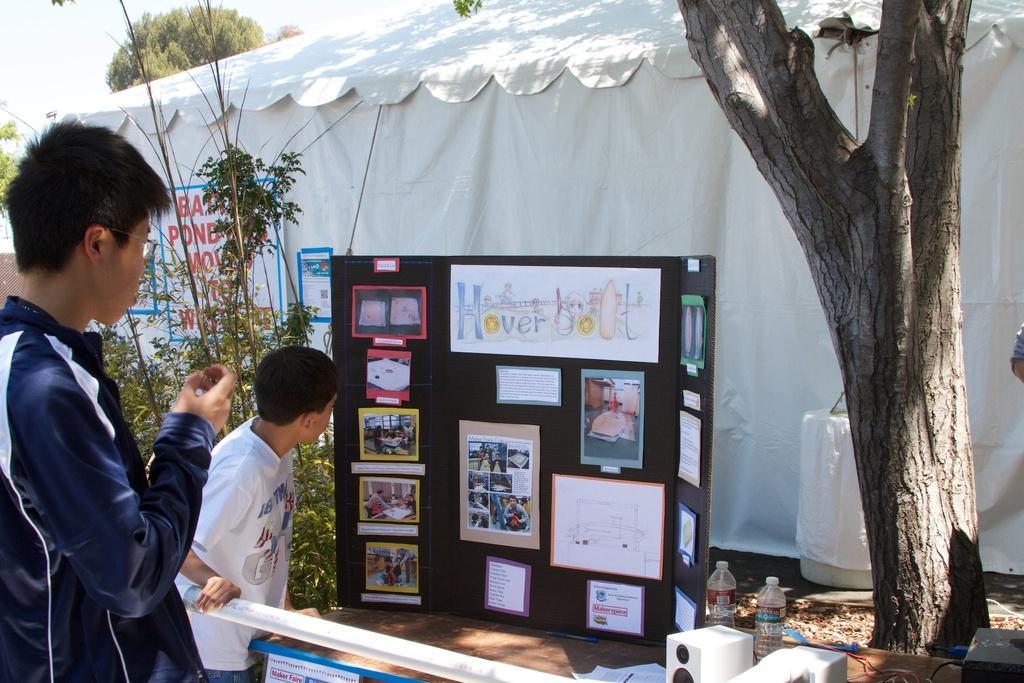Could you give a brief overview of what you see in this image? In this image there are two people standing and looking at a board with some photographs in it. In the background of the image there is a metal rod fence, bottles of water, some objects, trees, plants, and a tent with a banner on it. 